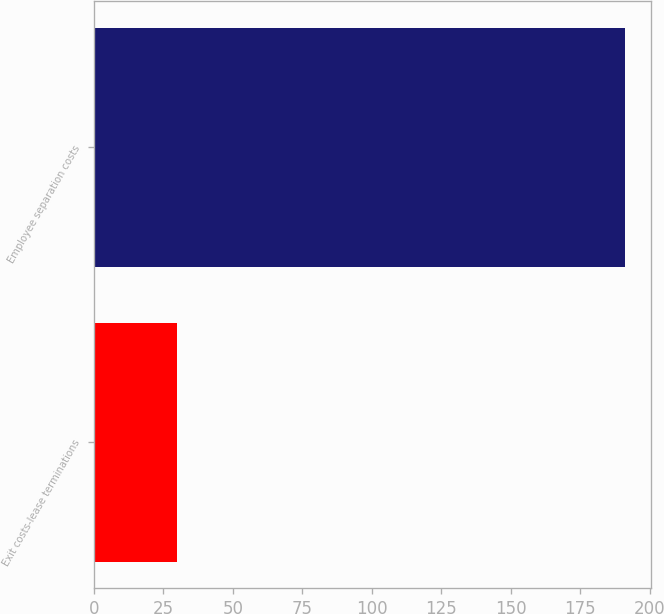Convert chart to OTSL. <chart><loc_0><loc_0><loc_500><loc_500><bar_chart><fcel>Exit costs-lease terminations<fcel>Employee separation costs<nl><fcel>30<fcel>191<nl></chart> 